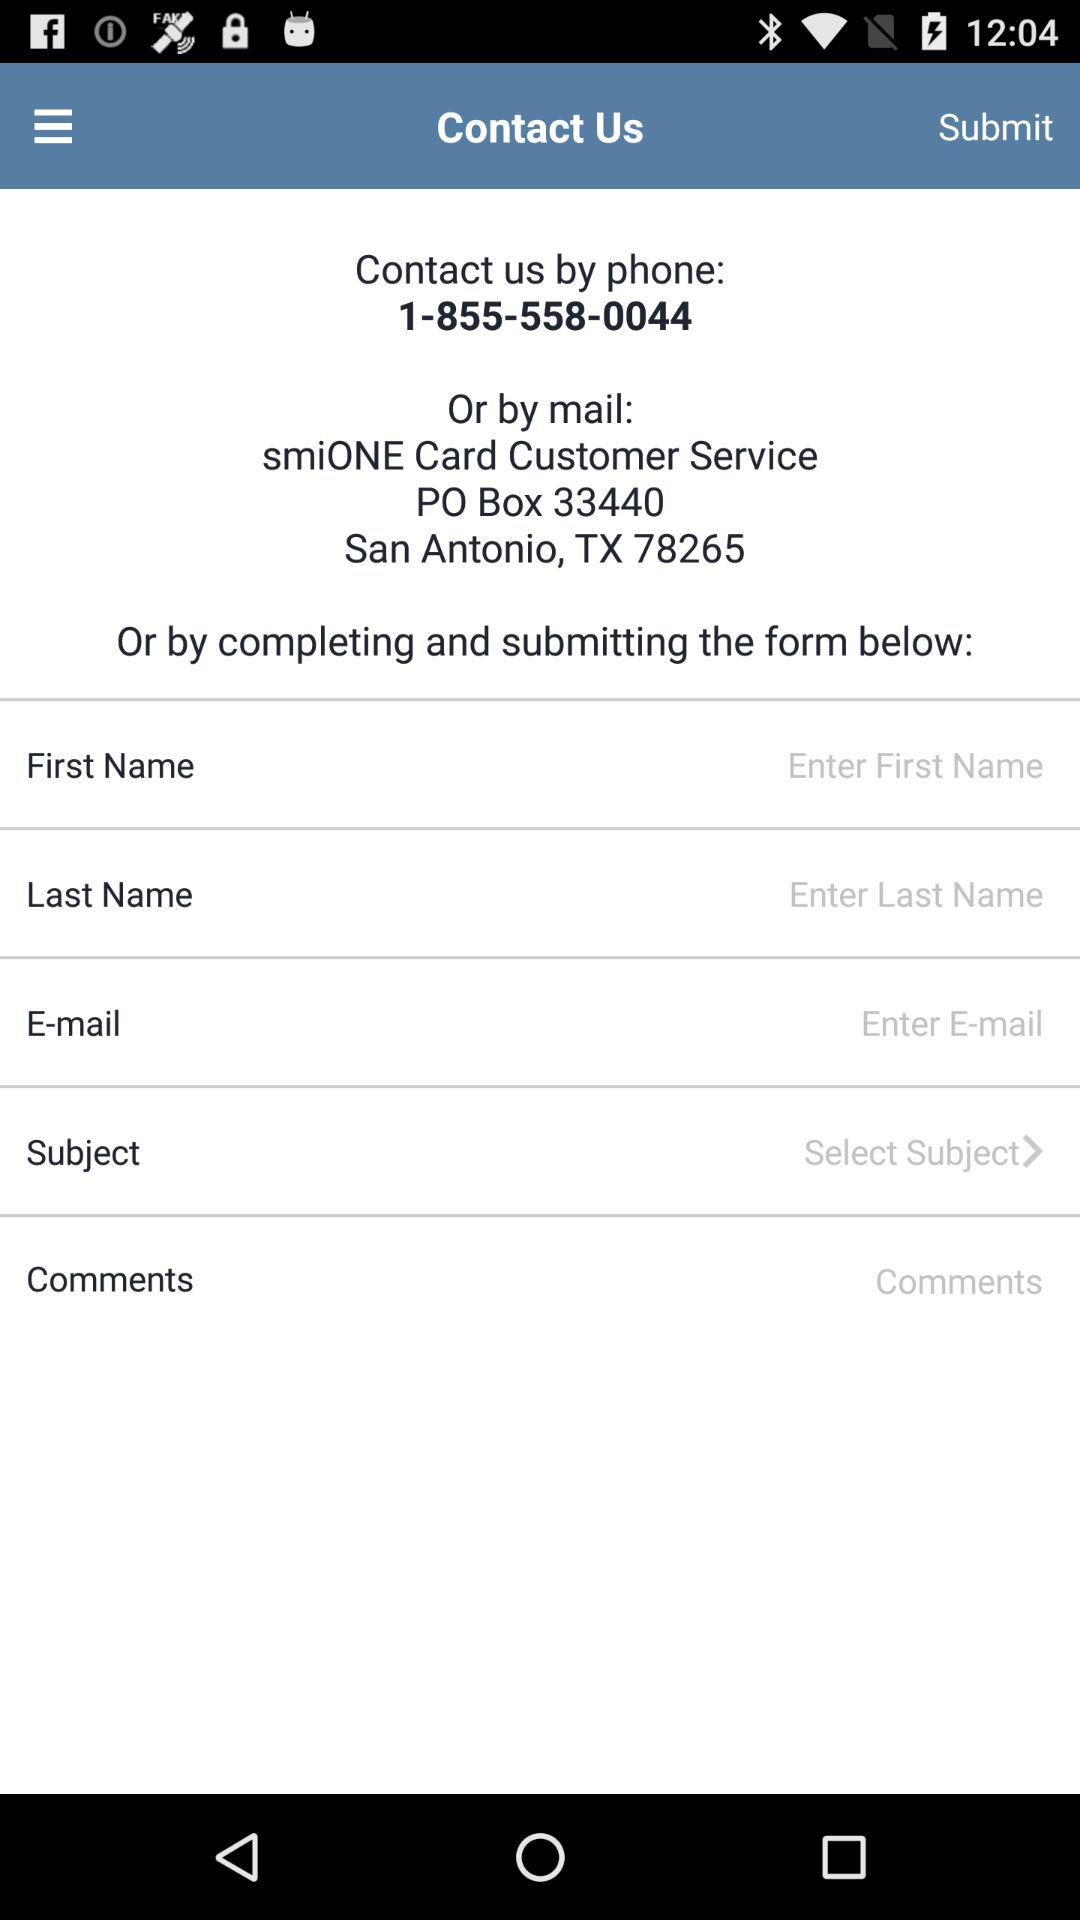What is the address? The address is "smiONE Card Customer Service PO Box 33440 San Antonio, TX 78265". 